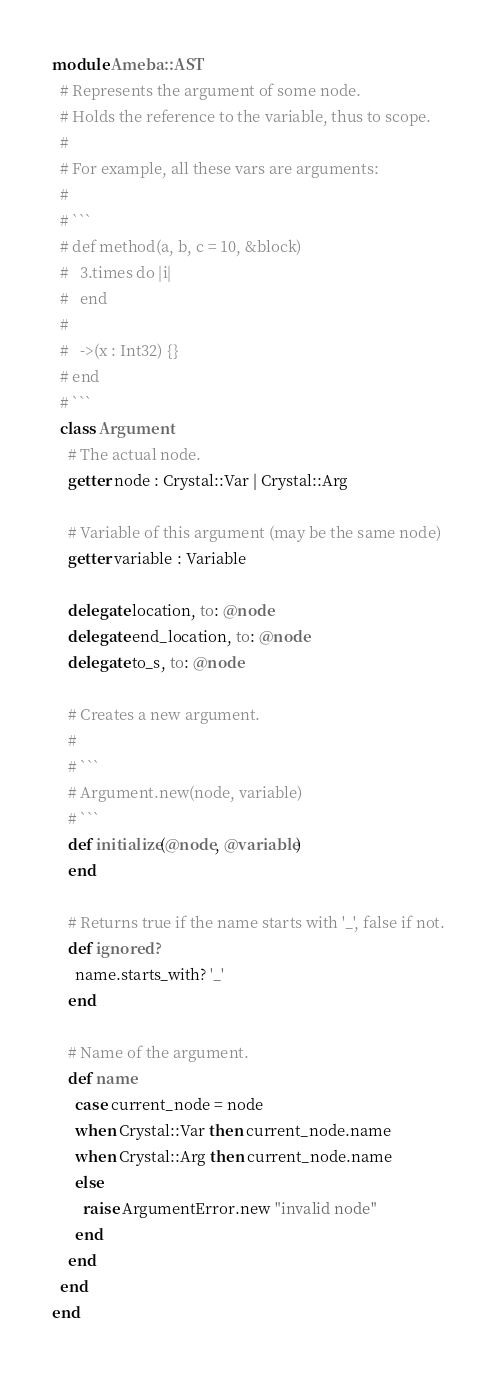<code> <loc_0><loc_0><loc_500><loc_500><_Crystal_>module Ameba::AST
  # Represents the argument of some node.
  # Holds the reference to the variable, thus to scope.
  #
  # For example, all these vars are arguments:
  #
  # ```
  # def method(a, b, c = 10, &block)
  #   3.times do |i|
  #   end
  #
  #   ->(x : Int32) {}
  # end
  # ```
  class Argument
    # The actual node.
    getter node : Crystal::Var | Crystal::Arg

    # Variable of this argument (may be the same node)
    getter variable : Variable

    delegate location, to: @node
    delegate end_location, to: @node
    delegate to_s, to: @node

    # Creates a new argument.
    #
    # ```
    # Argument.new(node, variable)
    # ```
    def initialize(@node, @variable)
    end

    # Returns true if the name starts with '_', false if not.
    def ignored?
      name.starts_with? '_'
    end

    # Name of the argument.
    def name
      case current_node = node
      when Crystal::Var then current_node.name
      when Crystal::Arg then current_node.name
      else
        raise ArgumentError.new "invalid node"
      end
    end
  end
end
</code> 